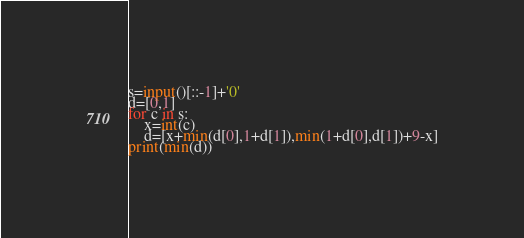<code> <loc_0><loc_0><loc_500><loc_500><_Python_>s=input()[::-1]+'0'
d=[0,1]
for c in s:
    x=int(c)
    d=[x+min(d[0],1+d[1]),min(1+d[0],d[1])+9-x]
print(min(d))
</code> 